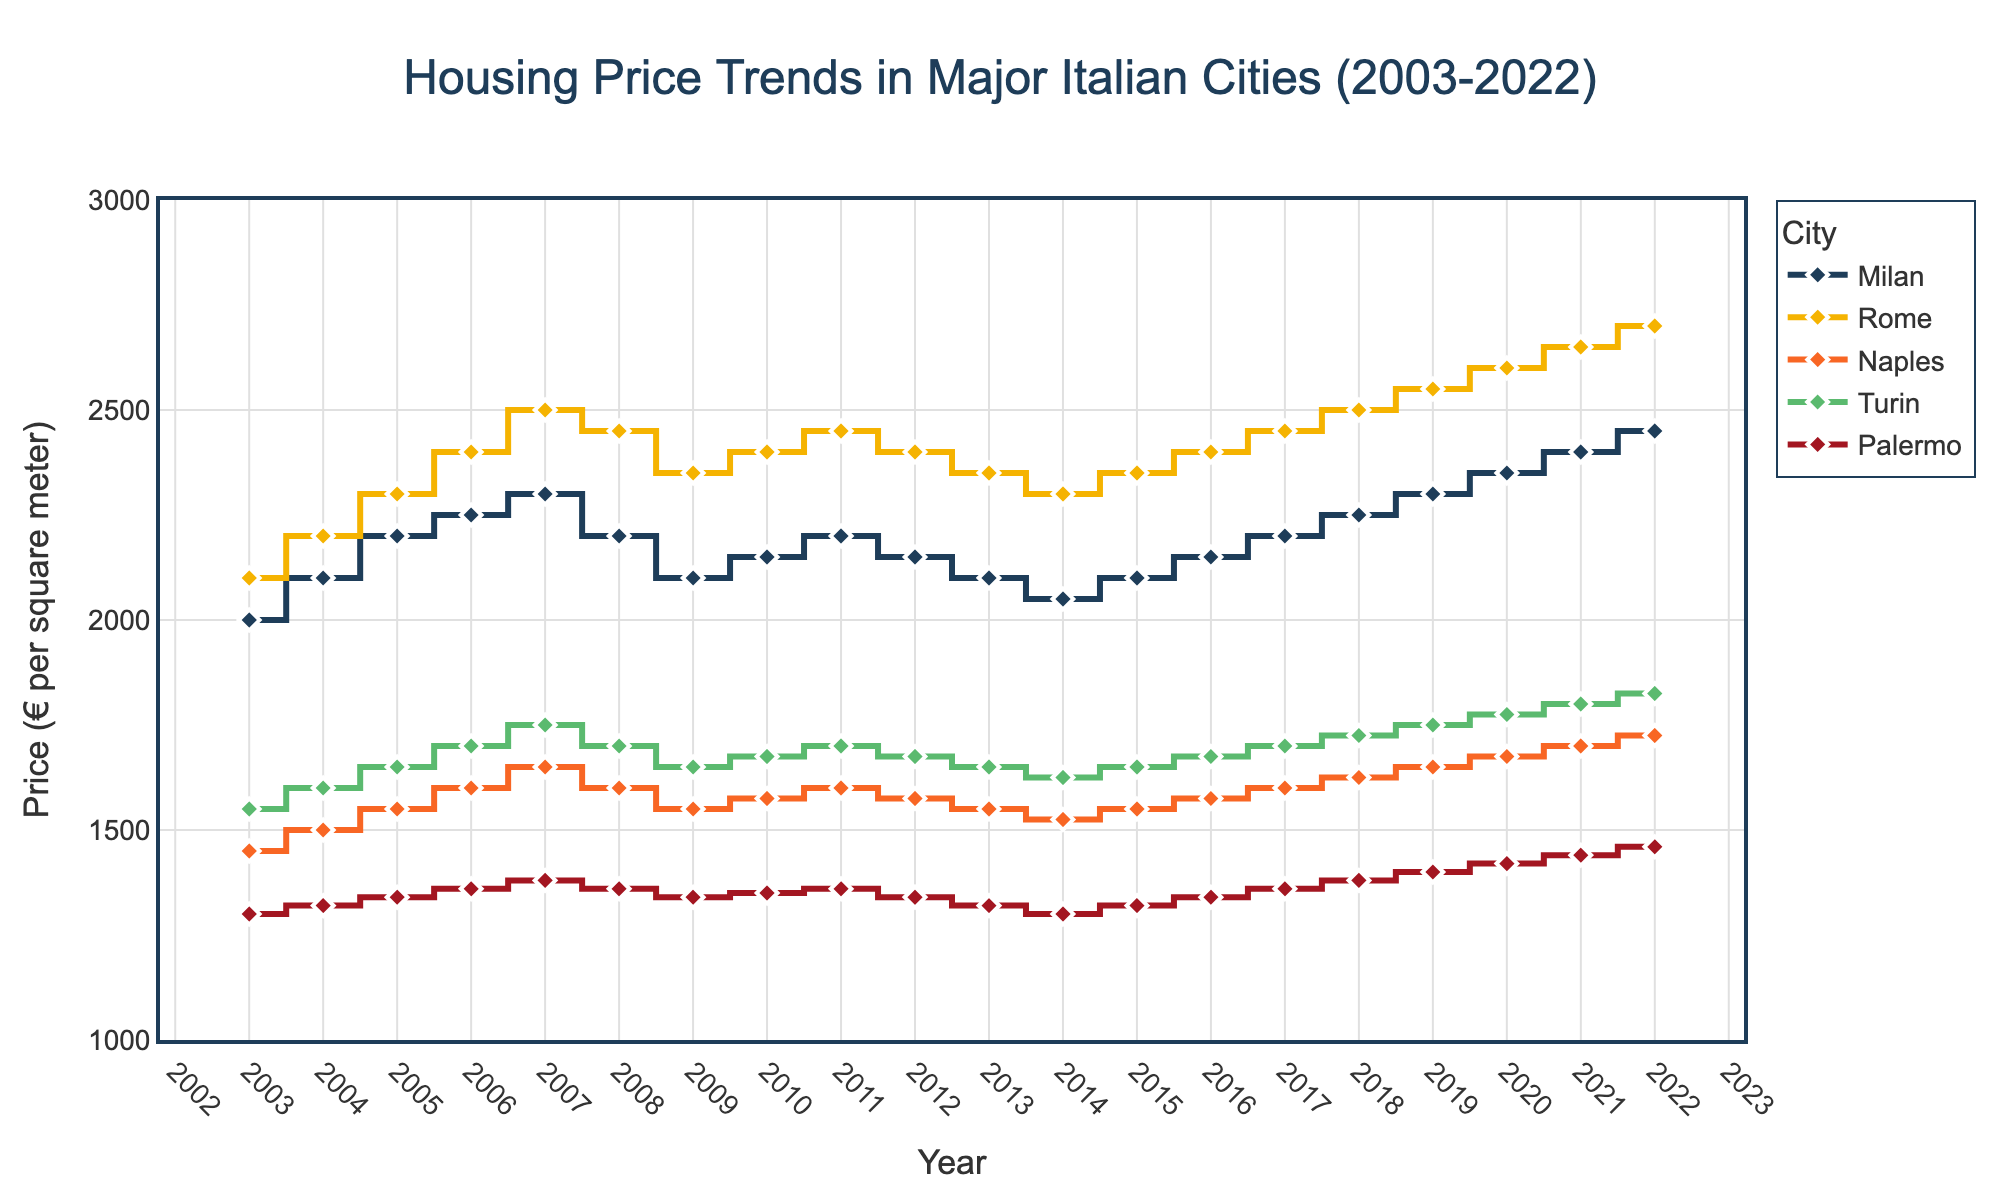What's the trend in housing prices in Milan from 2003 to 2022? The plot shows the housing prices in Milan with markers and a stair-line pattern. Observing the blue line, you can see that Milan's prices generally increased despite some dips around 2008-2014. Starting from €2000 in 2003, it ends at €2450 in 2022.
Answer: Increasing Which city had the highest housing price in 2007? In 2007, looking at the stair positions, Rome had the highest housing price. The yellow line symbolizing Rome shows a value of €2500 in 2007, higher than the others that year.
Answer: Rome Calculate the average housing price in Naples for the years 2015 to 2022. To calculate the average price for Naples between 2015 and 2022, consider the yearly prices— €1550, €1575, €1600, €1625, €1650, €1675, €1700, and €1725. Sum them: 1550 + 1575 + 1600 + 1625 + 1650 + 1675 + 1700 + 1725 = €13100. There are 8 years. So, the average price is €13100 / 8 = €1637.5.
Answer: €1637.5 Between which years did Turin experience a steady housing price in the plot? Observing the plot, Turin experienced steady housing prices during the period of 2008 to 2009. The green line representing Turin shows a horizontal pattern in this range, maintaining a price of €1700 throughout these years.
Answer: 2008-2009 How does the housing price trend in Palermo compare to that in Turin from 2010 to 2022? To compare Palermo and Turin, observe the respective lines for this period. Palermo (red line) steadily increased from approximately €1350 to €1460, while Turin (green line) saw more variation, starting at around €1675 and ending at €1825. Palermo shows a steady rise, whereas Turin experienced more fluctuations but generally had higher prices.
Answer: Palermo had a steady rise; Turin had fluctuating but higher prices Which city shows the greatest fluctuation in housing prices over the 20-year period? Analyzing the plot, Rome (yellow line) shows the greatest fluctuation with peak values around 2007, a decrease around 2008, a slight increase, and then another dip around 2013, and finally a constant rise up to 2022.
Answer: Rome In what year did Milan's housing prices fall below €2100 after 2006? Observing the line chart, Milan's prices fell below €2100 in 2008 and remained below this threshold until 2010 when they started rising again.
Answer: 2008 What was the price difference between Milan and Rome in 2022? In 2022, Milan’s housing price was €2450, while Rome's was €2700. The difference is obtained by subtracting €2450 from €2700, which is €2700 - €2450 = €250.
Answer: €250 Which city had the lowest housing price in 2012? In 2012, Palermo had the lowest housing price. The pink line representing Palermo shows the lowest price of €1340 compared to other cities in that year.
Answer: Palermo 